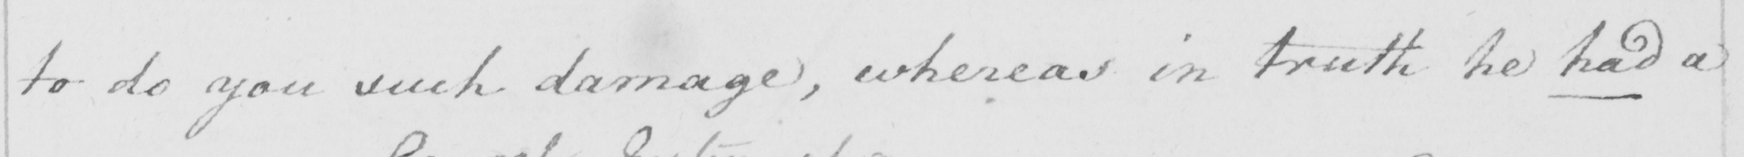What is written in this line of handwriting? to do you such damage, whereas in truth he had a 